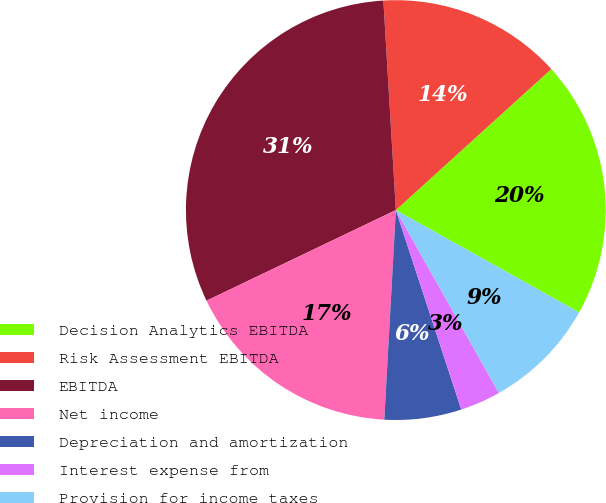Convert chart. <chart><loc_0><loc_0><loc_500><loc_500><pie_chart><fcel>Decision Analytics EBITDA<fcel>Risk Assessment EBITDA<fcel>EBITDA<fcel>Net income<fcel>Depreciation and amortization<fcel>Interest expense from<fcel>Provision for income taxes<nl><fcel>19.83%<fcel>14.22%<fcel>31.16%<fcel>17.02%<fcel>5.92%<fcel>3.12%<fcel>8.73%<nl></chart> 